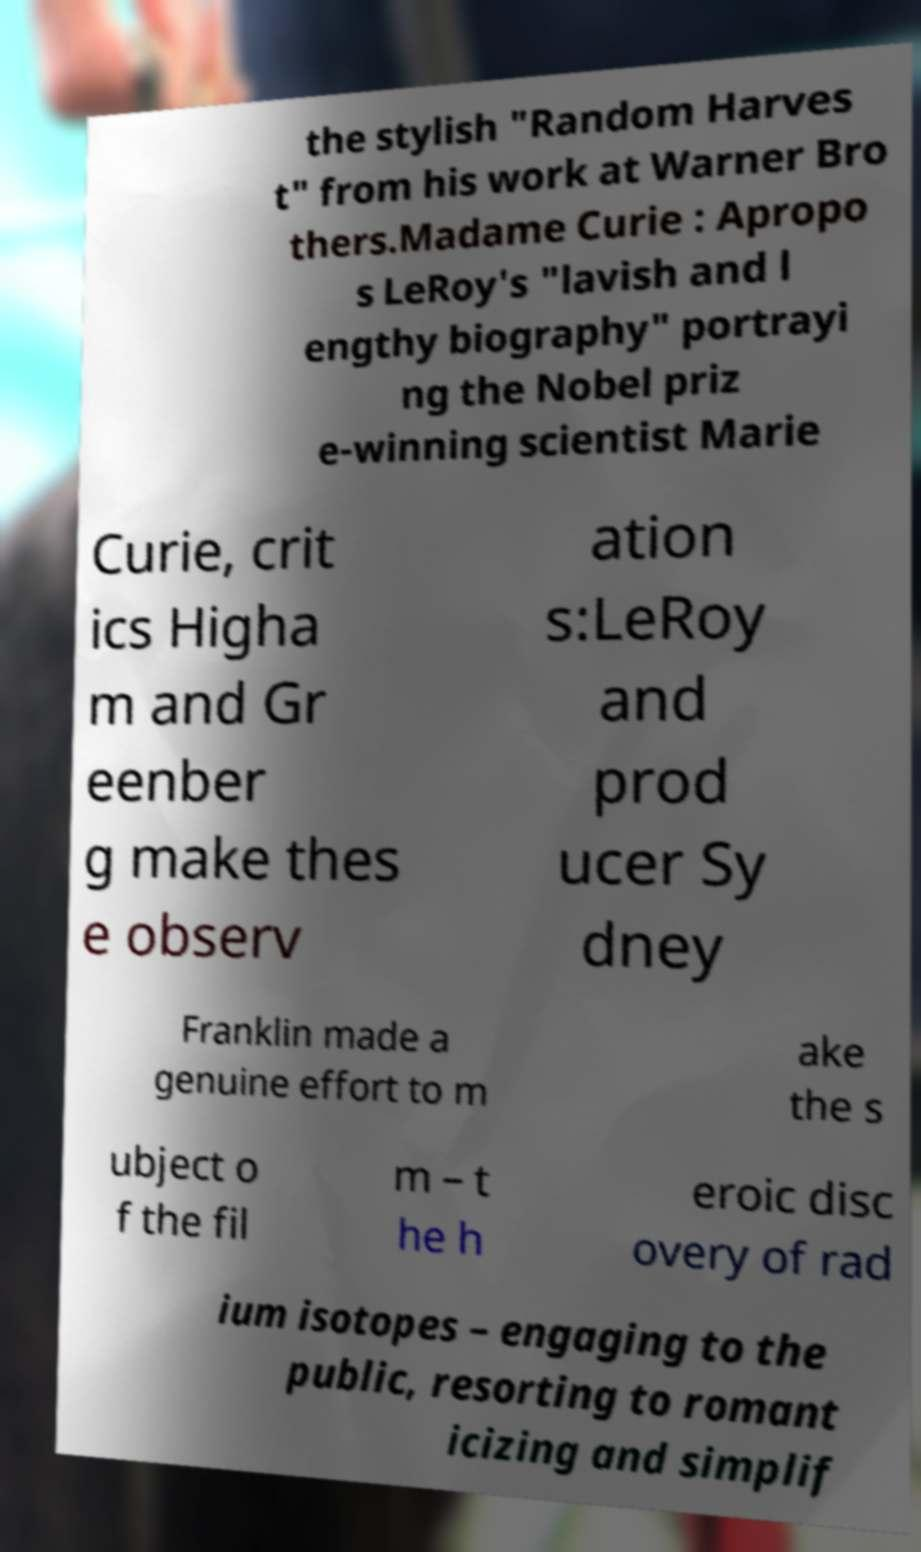Could you assist in decoding the text presented in this image and type it out clearly? the stylish "Random Harves t" from his work at Warner Bro thers.Madame Curie : Apropo s LeRoy's "lavish and l engthy biography" portrayi ng the Nobel priz e-winning scientist Marie Curie, crit ics Higha m and Gr eenber g make thes e observ ation s:LeRoy and prod ucer Sy dney Franklin made a genuine effort to m ake the s ubject o f the fil m – t he h eroic disc overy of rad ium isotopes – engaging to the public, resorting to romant icizing and simplif 